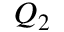<formula> <loc_0><loc_0><loc_500><loc_500>Q _ { 2 }</formula> 